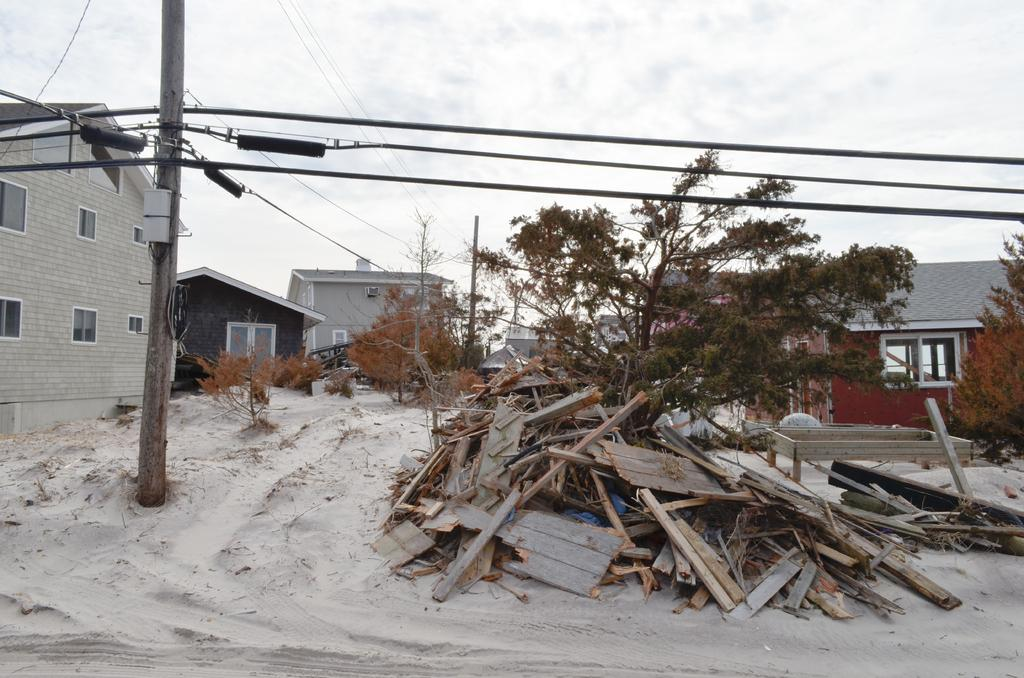What is attached to the pole in the image? There are wires attached to the pole in the image. What type of surface is on the ground in the image? There is sand on the ground in the image. What type of material is used for the pieces on the ground? The pieces on the ground are made of wood. What type of vegetation is present in the image? There are trees in the image. What type of structures can be seen in the image? There are buildings with windows in the image. What is visible in the background of the image? The sky is visible in the background of the image. What type of game is being played with the fang in the image? There is no game or fang present in the image. What type of engine is visible in the image? There is no engine present in the image. 